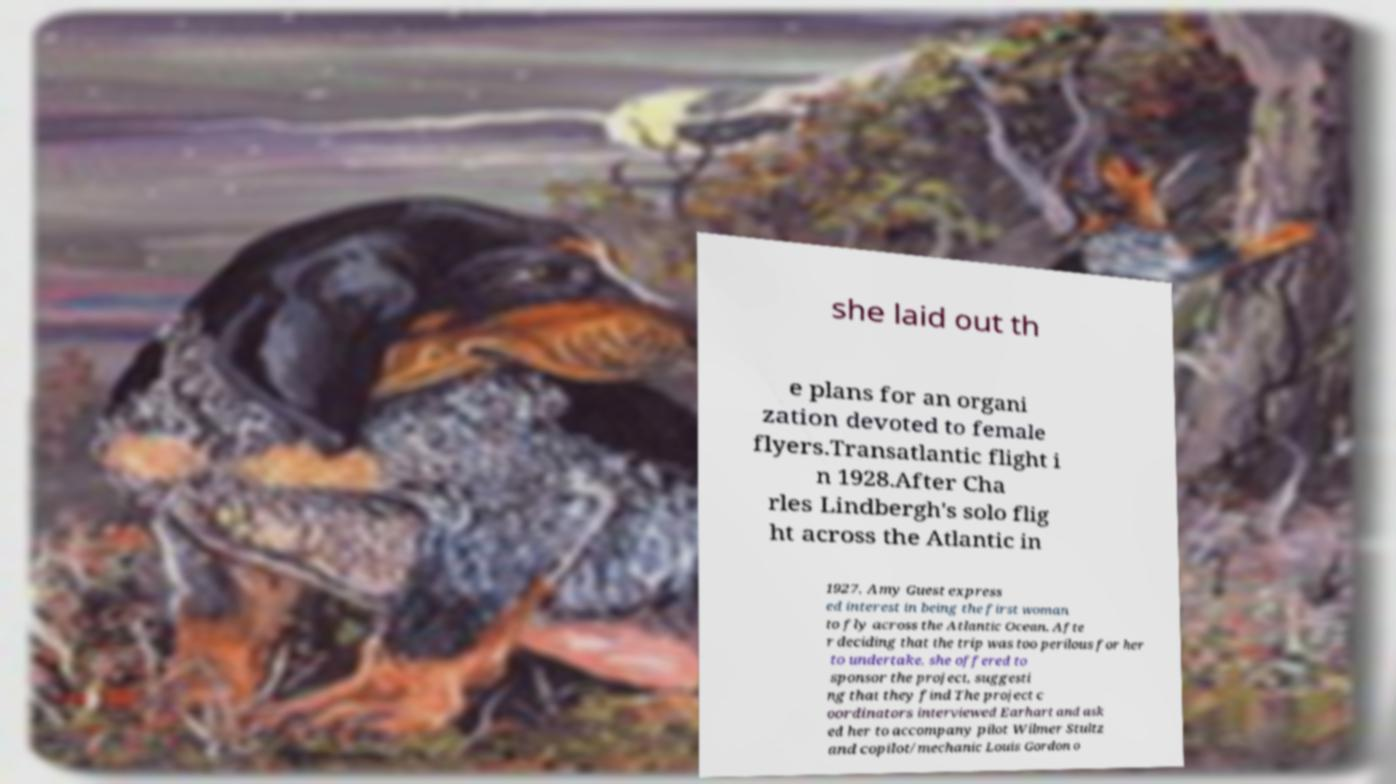Please identify and transcribe the text found in this image. she laid out th e plans for an organi zation devoted to female flyers.Transatlantic flight i n 1928.After Cha rles Lindbergh's solo flig ht across the Atlantic in 1927, Amy Guest express ed interest in being the first woman to fly across the Atlantic Ocean. Afte r deciding that the trip was too perilous for her to undertake, she offered to sponsor the project, suggesti ng that they find The project c oordinators interviewed Earhart and ask ed her to accompany pilot Wilmer Stultz and copilot/mechanic Louis Gordon o 